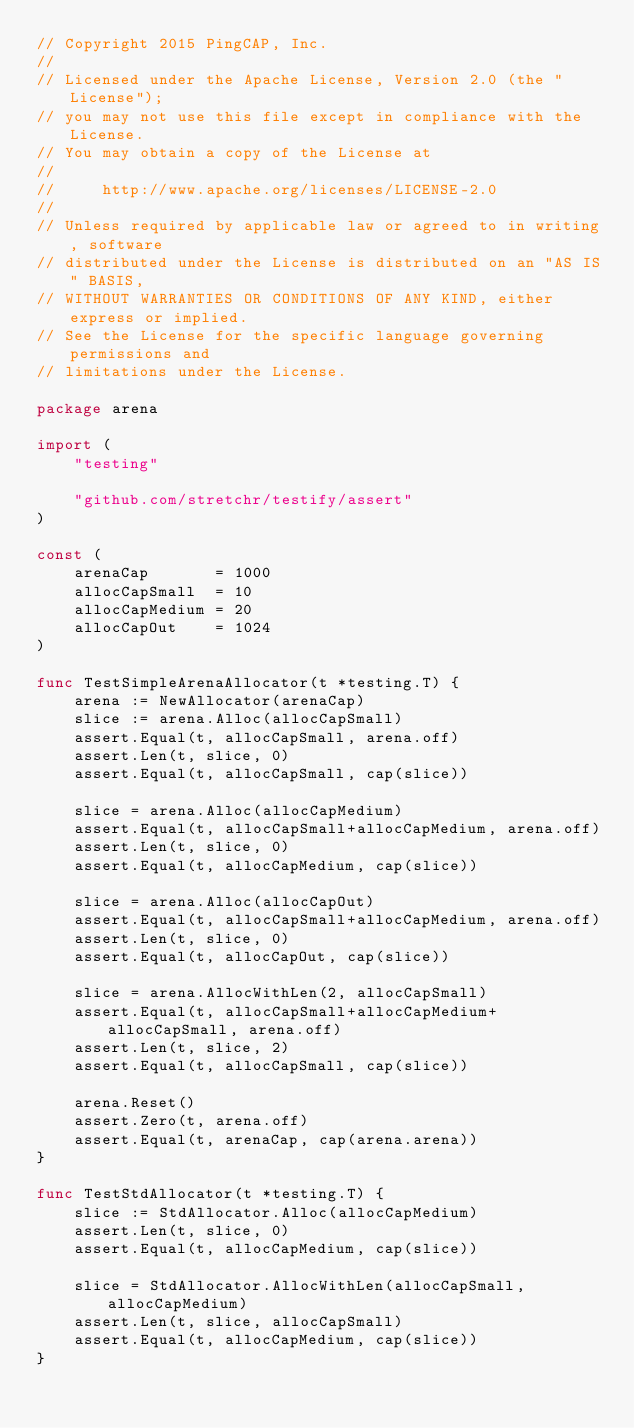Convert code to text. <code><loc_0><loc_0><loc_500><loc_500><_Go_>// Copyright 2015 PingCAP, Inc.
//
// Licensed under the Apache License, Version 2.0 (the "License");
// you may not use this file except in compliance with the License.
// You may obtain a copy of the License at
//
//     http://www.apache.org/licenses/LICENSE-2.0
//
// Unless required by applicable law or agreed to in writing, software
// distributed under the License is distributed on an "AS IS" BASIS,
// WITHOUT WARRANTIES OR CONDITIONS OF ANY KIND, either express or implied.
// See the License for the specific language governing permissions and
// limitations under the License.

package arena

import (
	"testing"

	"github.com/stretchr/testify/assert"
)

const (
	arenaCap       = 1000
	allocCapSmall  = 10
	allocCapMedium = 20
	allocCapOut    = 1024
)

func TestSimpleArenaAllocator(t *testing.T) {
	arena := NewAllocator(arenaCap)
	slice := arena.Alloc(allocCapSmall)
	assert.Equal(t, allocCapSmall, arena.off)
	assert.Len(t, slice, 0)
	assert.Equal(t, allocCapSmall, cap(slice))

	slice = arena.Alloc(allocCapMedium)
	assert.Equal(t, allocCapSmall+allocCapMedium, arena.off)
	assert.Len(t, slice, 0)
	assert.Equal(t, allocCapMedium, cap(slice))

	slice = arena.Alloc(allocCapOut)
	assert.Equal(t, allocCapSmall+allocCapMedium, arena.off)
	assert.Len(t, slice, 0)
	assert.Equal(t, allocCapOut, cap(slice))

	slice = arena.AllocWithLen(2, allocCapSmall)
	assert.Equal(t, allocCapSmall+allocCapMedium+allocCapSmall, arena.off)
	assert.Len(t, slice, 2)
	assert.Equal(t, allocCapSmall, cap(slice))

	arena.Reset()
	assert.Zero(t, arena.off)
	assert.Equal(t, arenaCap, cap(arena.arena))
}

func TestStdAllocator(t *testing.T) {
	slice := StdAllocator.Alloc(allocCapMedium)
	assert.Len(t, slice, 0)
	assert.Equal(t, allocCapMedium, cap(slice))

	slice = StdAllocator.AllocWithLen(allocCapSmall, allocCapMedium)
	assert.Len(t, slice, allocCapSmall)
	assert.Equal(t, allocCapMedium, cap(slice))
}
</code> 